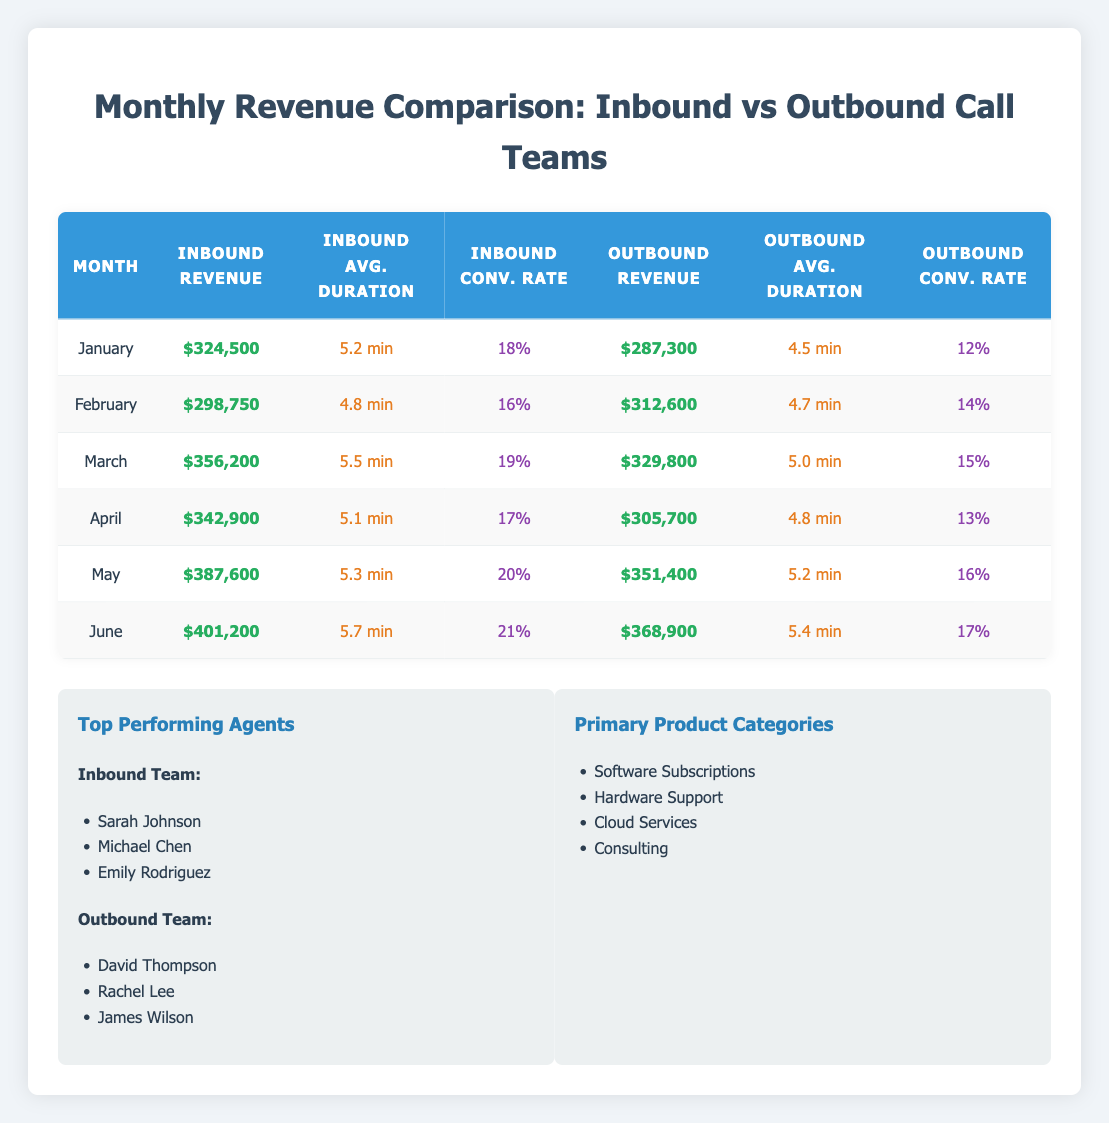What's the total revenue generated by the inbound team in March? The revenue for the inbound team in March is listed as $356,200.
Answer: $356,200 What was the average call duration for the outbound team in May? The average call duration for the outbound team in May is given as 5.2 minutes.
Answer: 5.2 min Which month experienced the highest revenue for the inbound team? By reviewing the revenue column for the inbound team, June has the highest revenue of $401,200.
Answer: June Is the conversion rate for the inbound team in April greater than 15%? The conversion rate for the inbound team in April is 17%, which is greater than 15%.
Answer: Yes Calculate the difference in revenue between the inbound and outbound teams in January. The inbound team revenue in January is $324,500 and outbound revenue is $287,300. The difference is $324,500 - $287,300 = $37,200.
Answer: $37,200 In which month did the outbound team have a higher conversion rate than the inbound team? Looking at the conversion rates, the outbound team had a higher rate than the inbound only in February, with 14% versus the inbound's 16%.
Answer: No What is the total revenue for the inbound team over the six months? To find the total, sum the revenues from January to June: $324,500 + $298,750 + $356,200 + $342,900 + $387,600 + $401,200 = $2,111,150.
Answer: $2,111,150 What is the average conversion rate of the outbound team across all months? Adding the conversion rates of the outbound team: (0.12 + 0.14 + 0.15 + 0.13 + 0.16 + 0.17) = 0.87. Dividing by the number of months (6), the average conversion rate is 0.87 / 6 = 0.145 or 14.5%.
Answer: 14.5% Which team had a higher average call duration over the six months? The average call durations need to be calculated: Inbound total is (5.2 + 4.8 + 5.5 + 5.1 + 5.3 + 5.7) = 31.6 and average is 31.6 / 6 = 5.27 minutes. Outbound total is (4.5 + 4.7 + 5.0 + 4.8 + 5.2 + 5.4) = 29.6 and average is 29.6 / 6 = 4.93 minutes. Inbound has a higher average of 5.27 minutes compared to outbound's 4.93 minutes.
Answer: Inbound team Is at least one of the top-performing agents from the outbound team involved in consulting? The table does not specify the products associated with the agents, so we cannot confirm if any of the outbound team agents are involved in consulting.
Answer: No 